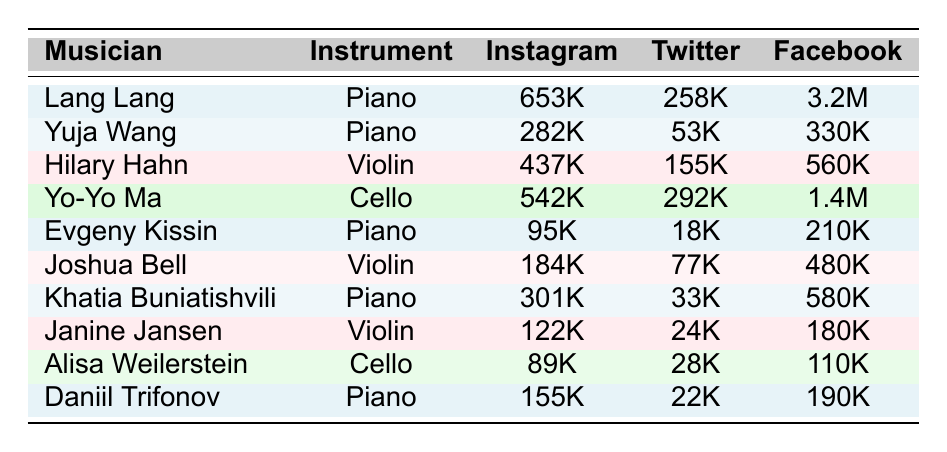What is the Instagram follower count of Lang Lang? The table shows that Lang Lang has 653,000 Instagram followers listed under the "Instagram" column associated with his name.
Answer: 653K Which musician has the highest Facebook likes? By examining the "Facebook" column in the table, Yo-Yo Ma has the most likes at 1,400,000.
Answer: Yo-Yo Ma Calculate the total Instagram followers for all pianists. The Instagram followers for the pianists are: Lang Lang (653K), Yuja Wang (282K), Evgeny Kissin (95K), Khatia Buniatishvili (301K), and Daniil Trifonov (155K). Adding these gives: 653 + 282 + 95 + 301 + 155 = 1486K followers.
Answer: 1486K Is Hilary Hahn's follower count higher on Twitter than on Instagram? Hilary Hahn has 155,000 Twitter followers and 437,000 Instagram followers. Since 155K < 437K, the statement is false.
Answer: No Which musician has the lowest Twitter followers? After checking the "Twitter" column, Evgeny Kissin has the fewest followers with only 18,000.
Answer: Evgeny Kissin Calculate the average Facebook likes for string musicians. The string musicians and their likes are: Hilary Hahn (560K), Yo-Yo Ma (1.4M), Joshua Bell (480K), Janine Jansen (180K), and Alisa Weilerstein (110K). Summing them gives: 560 + 1400 + 480 + 180 + 110 = 2730K. The average is 2730K / 5 = 546K.
Answer: 546K Does Khatia Buniatishvili have more Instagram followers than Joshua Bell? Khatia Buniatishvili has 301,000 Instagram followers, while Joshua Bell has 184,000. Since 301K > 184K, the answer is true.
Answer: Yes What is the difference in Facebook likes between the most and least liked musicians? The most liked musician is Yo-Yo Ma with 1,400,000 likes, and the least liked musician is Alisa Weilerstein with 110,000 likes. The difference is: 1,400,000 - 110,000 = 1,290,000.
Answer: 1,290K Which pianist has the most Twitter followers? The Twitter followers for pianists are: Lang Lang (258K), Yuja Wang (53K), Evgeny Kissin (18K), Khatia Buniatishvili (33K), and Daniil Trifonov (22K). Lang Lang has the most with 258,000.
Answer: Lang Lang If you combine the Instagram followers of all musicians, which instrument category would result in a higher total? Pianists have a total of 1,486K followers and string musicians have 1,332K (Hilary Hahn 437K, Yo-Yo Ma 542K, Joshua Bell 184K, Janine Jansen 122K, Alisa Weilerstein 89K). Comparing, 1,486K > 1,332K, so pianists have more.
Answer: Pianists 